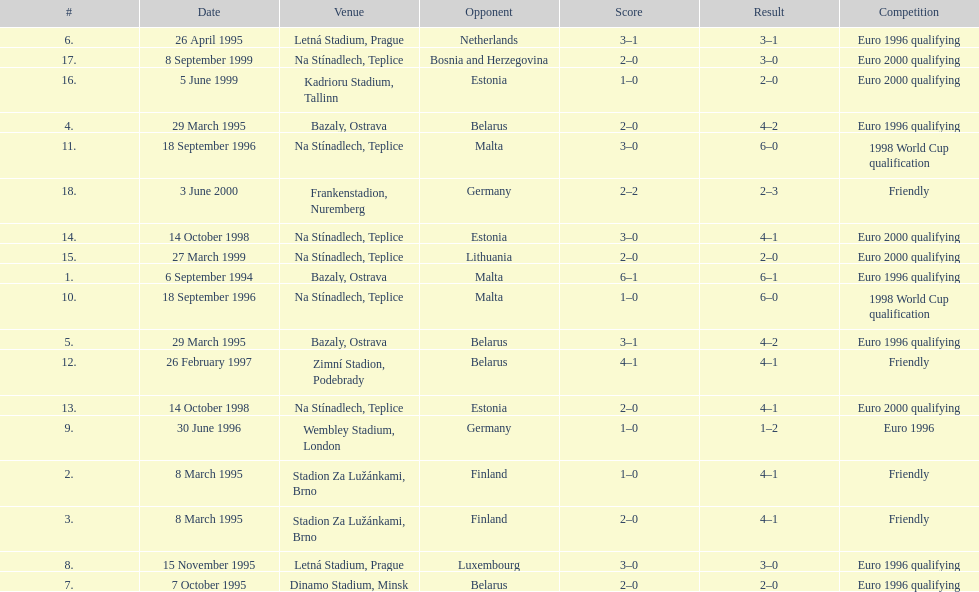What venue is listed above wembley stadium, london? Letná Stadium, Prague. 